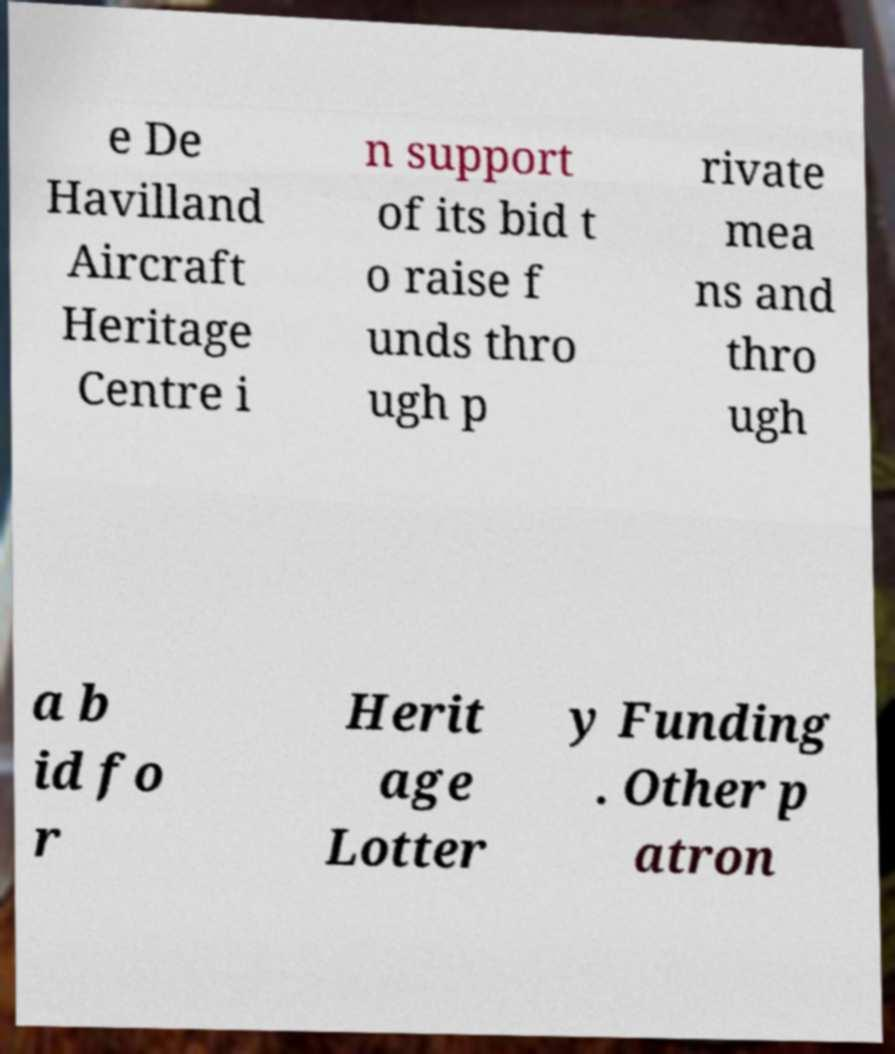Can you read and provide the text displayed in the image?This photo seems to have some interesting text. Can you extract and type it out for me? e De Havilland Aircraft Heritage Centre i n support of its bid t o raise f unds thro ugh p rivate mea ns and thro ugh a b id fo r Herit age Lotter y Funding . Other p atron 